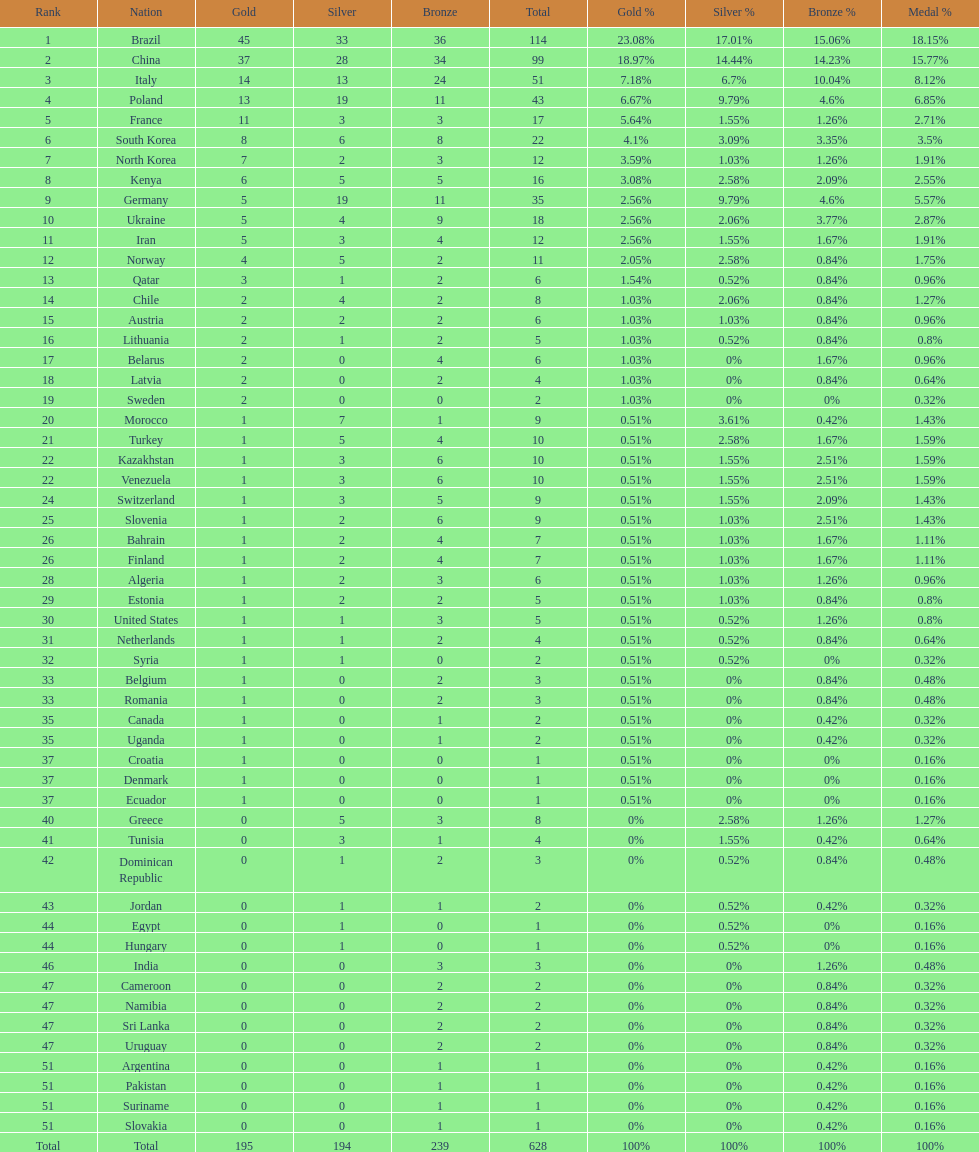Which type of medal does belarus not have? Silver. 